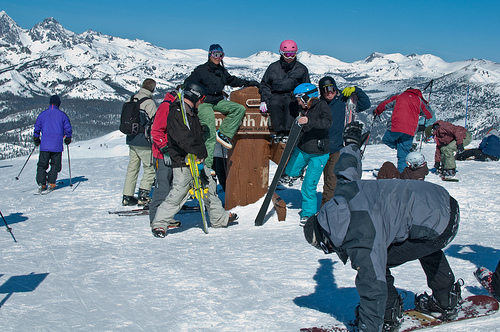Please transcribe the text information in this image. n th M k 